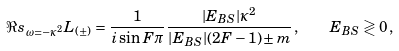<formula> <loc_0><loc_0><loc_500><loc_500>\Re s _ { \omega = - \kappa ^ { 2 } } L _ { ( \pm ) } = \frac { 1 } { i \sin F \pi } \frac { | E _ { B S } | \kappa ^ { 2 } } { | E _ { B S } | ( 2 F - 1 ) \pm m } \, , \quad E _ { B S } \gtrless 0 \, ,</formula> 